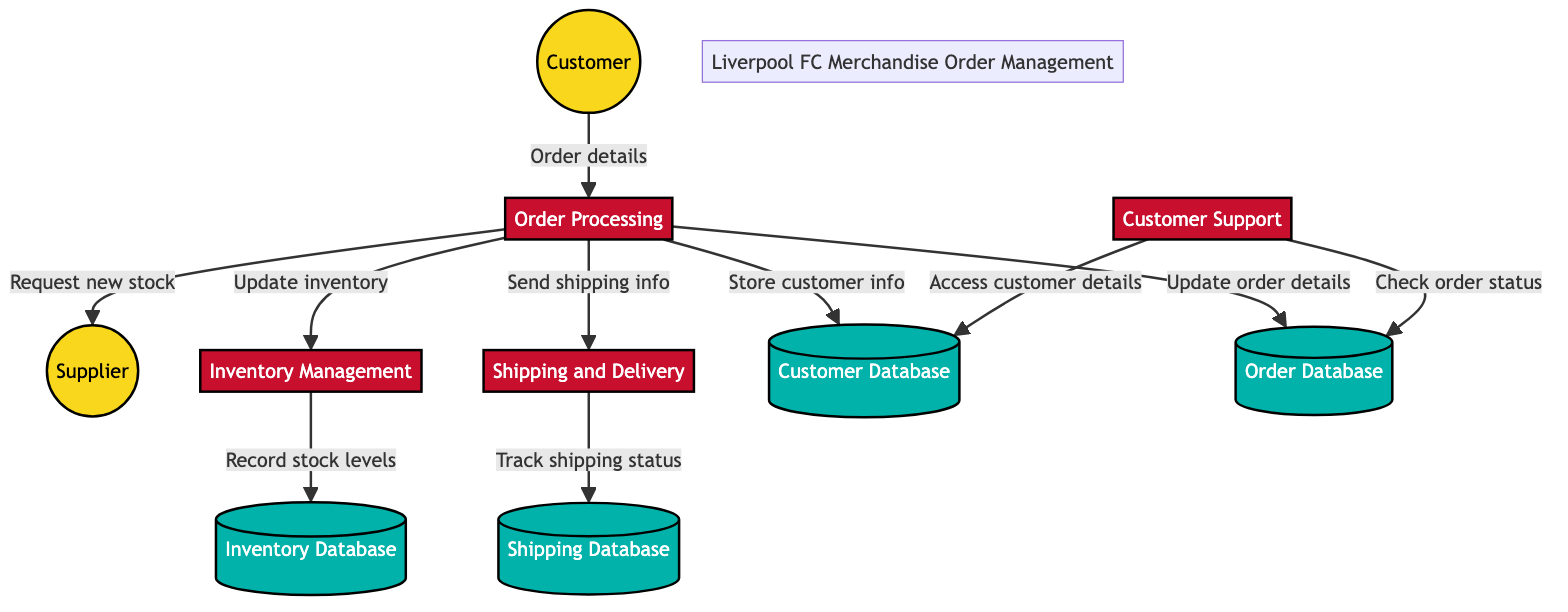What is the purpose of the Order Processing process? The Order Processing process handles the customer's order from submission to payment processing. It is the primary process that initiates and manages the order fulfillment cycle.
Answer: Handles orders How many external entities are shown in the diagram? There are two external entities in the diagram: Customer and Supplier. These entities represent the sources and recipients of the data flows related to merchandise orders.
Answer: 2 Which process updates the inventory levels? The Inventory Management process is responsible for updating inventory levels based on new orders that come from the Order Processing process.
Answer: Inventory Management What data store holds order status and payment information? The Order Database data store holds details of all placed orders, including their status and associated payment information.
Answer: Order Database What type of information does the Shipping Database store? The Shipping Database stores information related to shipping carriers and the delivery status of merchandise orders, helping to track the shipping process.
Answer: Shipping carriers and delivery status Where does Customer Support access customer details? Customer Support accesses customer details from the Customer Database, allowing them to provide assistance with inquiries and issues effectively.
Answer: Customer Database Which external entity does the Order Processing process request new stock from? The Order Processing process requests new stock from the Supplier when inventory levels are low, ensuring proper stock availability for fulfilling orders.
Answer: Supplier How many processes are involved in managing Liverpool FC merchandise orders? There are four processes involved in the system: Order Processing, Inventory Management, Shipping and Delivery, and Customer Support. Each process plays a crucial role in managing the overall order flow.
Answer: 4 Which data store is updated with new order details? The Order Database is updated with new order details, including the status and payment information as orders are processed by the system.
Answer: Order Database 